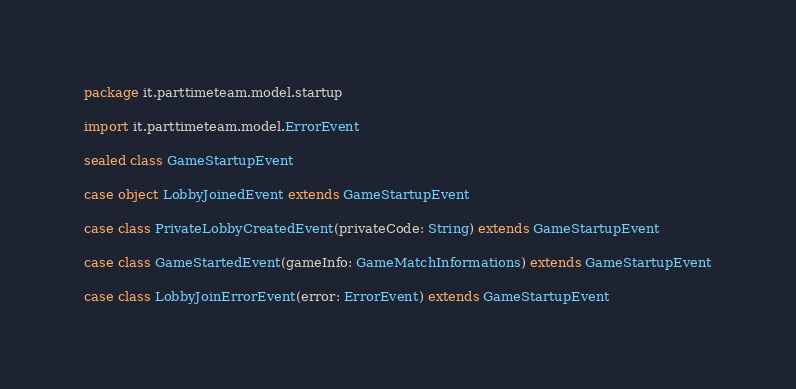Convert code to text. <code><loc_0><loc_0><loc_500><loc_500><_Scala_>package it.parttimeteam.model.startup

import it.parttimeteam.model.ErrorEvent

sealed class GameStartupEvent

case object LobbyJoinedEvent extends GameStartupEvent

case class PrivateLobbyCreatedEvent(privateCode: String) extends GameStartupEvent

case class GameStartedEvent(gameInfo: GameMatchInformations) extends GameStartupEvent

case class LobbyJoinErrorEvent(error: ErrorEvent) extends GameStartupEvent


</code> 